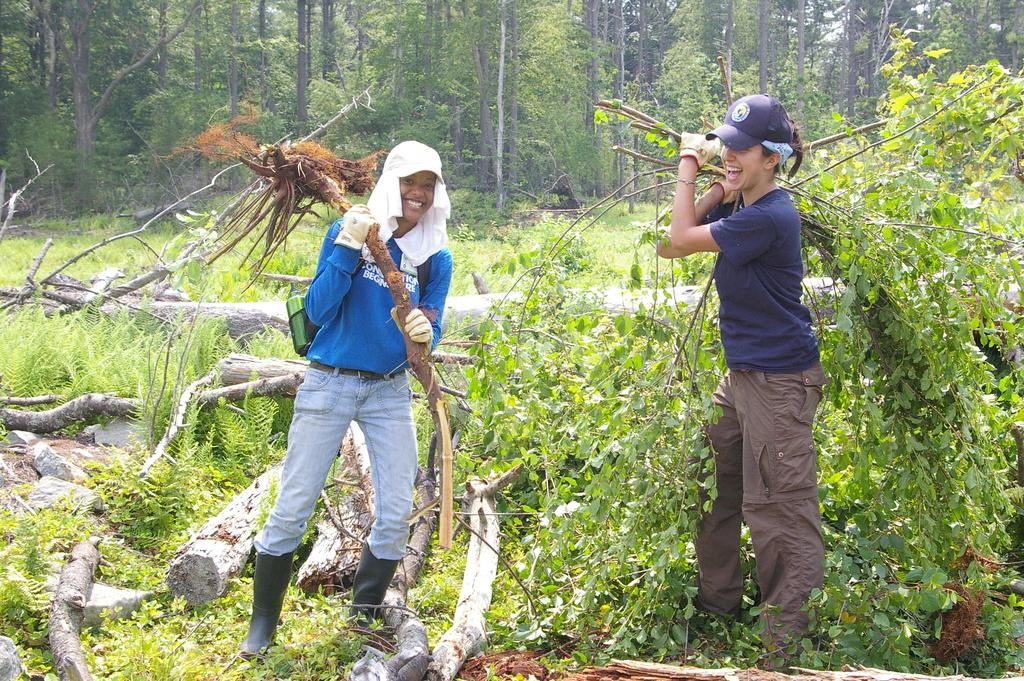How many people are in the image? There are two persons standing in the image. What is the facial expression of the persons? The persons are smiling. What is present on the ground in the image? There are plants and wood on the ground. What can be seen in the background of the image? There are trees in the background of the image. How many buckets of paint are being used by the persons in the image? There is no indication of any buckets of paint in the image. How long does it take for the can to be filled with water in the image? There is no can or water present in the image. 